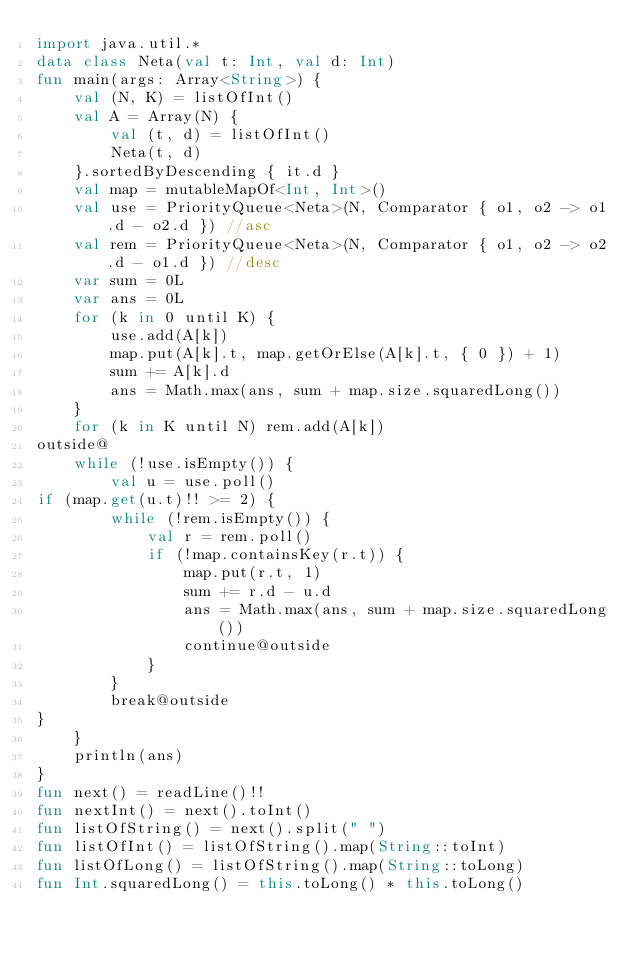Convert code to text. <code><loc_0><loc_0><loc_500><loc_500><_Kotlin_>import java.util.*
data class Neta(val t: Int, val d: Int)
fun main(args: Array<String>) {
    val (N, K) = listOfInt()
    val A = Array(N) {
        val (t, d) = listOfInt()
        Neta(t, d)
    }.sortedByDescending { it.d }
    val map = mutableMapOf<Int, Int>()
    val use = PriorityQueue<Neta>(N, Comparator { o1, o2 -> o1.d - o2.d }) //asc
    val rem = PriorityQueue<Neta>(N, Comparator { o1, o2 -> o2.d - o1.d }) //desc
    var sum = 0L
    var ans = 0L
    for (k in 0 until K) {
        use.add(A[k])
        map.put(A[k].t, map.getOrElse(A[k].t, { 0 }) + 1)
        sum += A[k].d
        ans = Math.max(ans, sum + map.size.squaredLong())
    }
    for (k in K until N) rem.add(A[k])
outside@
    while (!use.isEmpty()) {
        val u = use.poll()
if (map.get(u.t)!! >= 2) {
        while (!rem.isEmpty()) {
            val r = rem.poll()
            if (!map.containsKey(r.t)) {
                map.put(r.t, 1)
                sum += r.d - u.d
                ans = Math.max(ans, sum + map.size.squaredLong())
                continue@outside
            }
        }
        break@outside
}
    }
    println(ans)
}
fun next() = readLine()!!
fun nextInt() = next().toInt()
fun listOfString() = next().split(" ")
fun listOfInt() = listOfString().map(String::toInt)
fun listOfLong() = listOfString().map(String::toLong)
fun Int.squaredLong() = this.toLong() * this.toLong()
</code> 